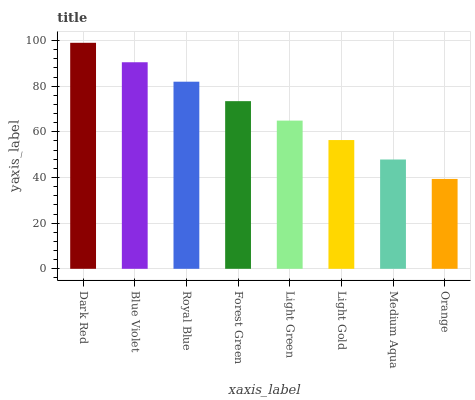Is Orange the minimum?
Answer yes or no. Yes. Is Dark Red the maximum?
Answer yes or no. Yes. Is Blue Violet the minimum?
Answer yes or no. No. Is Blue Violet the maximum?
Answer yes or no. No. Is Dark Red greater than Blue Violet?
Answer yes or no. Yes. Is Blue Violet less than Dark Red?
Answer yes or no. Yes. Is Blue Violet greater than Dark Red?
Answer yes or no. No. Is Dark Red less than Blue Violet?
Answer yes or no. No. Is Forest Green the high median?
Answer yes or no. Yes. Is Light Green the low median?
Answer yes or no. Yes. Is Light Gold the high median?
Answer yes or no. No. Is Blue Violet the low median?
Answer yes or no. No. 